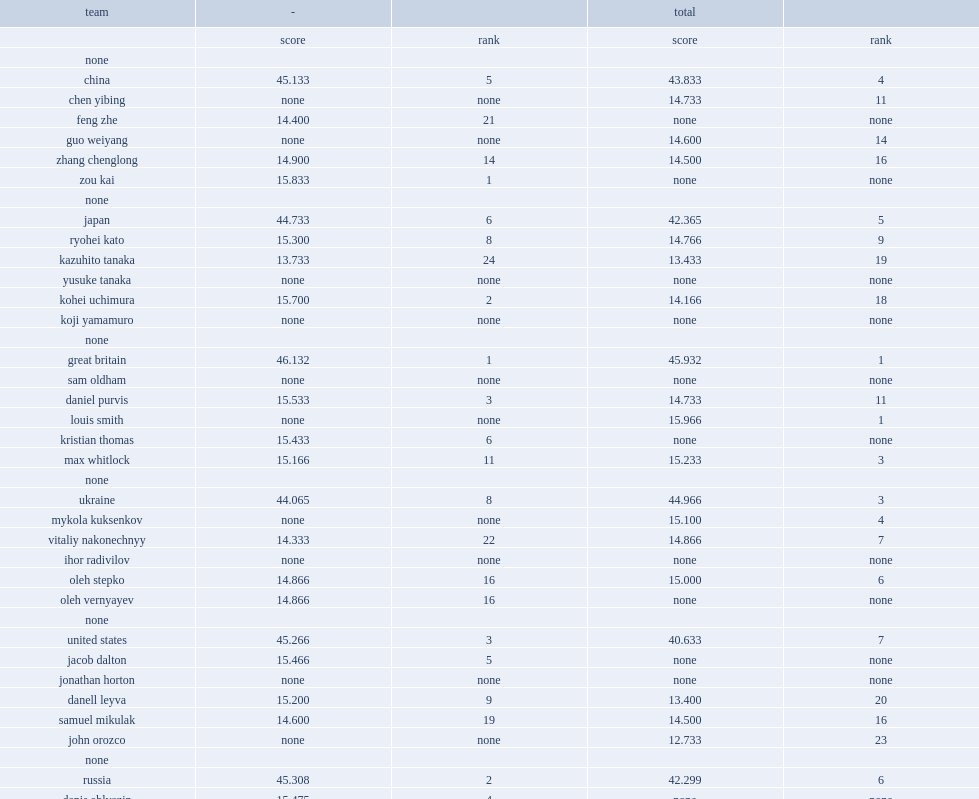Which country has a higher score? japan or the great britain? Japan. 